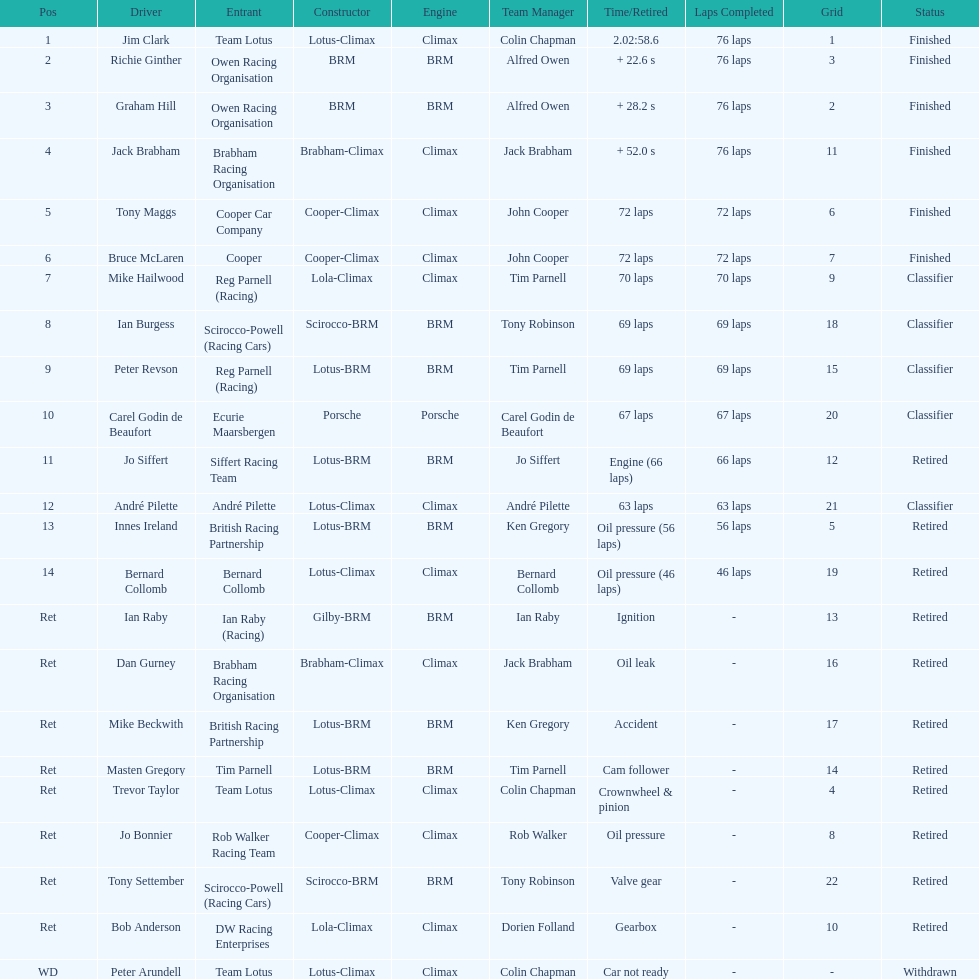Who was the top finisher that drove a cooper-climax? Tony Maggs. 